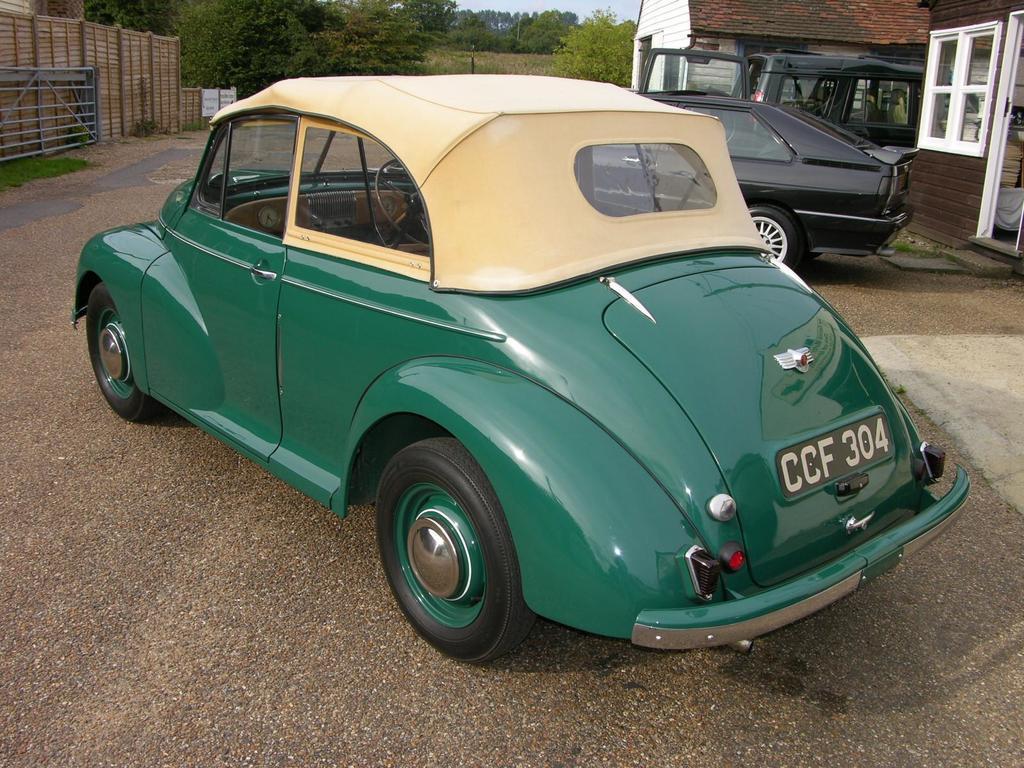How would you summarize this image in a sentence or two? In this picture we can see vehicles on the ground, gate, wall and houses with windows. In the background we can see trees and the sky. 